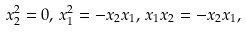Convert formula to latex. <formula><loc_0><loc_0><loc_500><loc_500>x _ { 2 } ^ { 2 } = 0 , \, x _ { 1 } ^ { 2 } = - x _ { 2 } x _ { 1 } , \, x _ { 1 } x _ { 2 } = - x _ { 2 } x _ { 1 } ,</formula> 